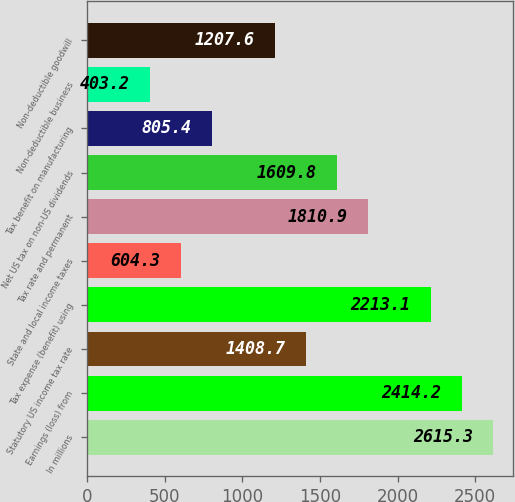<chart> <loc_0><loc_0><loc_500><loc_500><bar_chart><fcel>In millions<fcel>Earnings (loss) from<fcel>Statutory US income tax rate<fcel>Tax expense (benefit) using<fcel>State and local income taxes<fcel>Tax rate and permanent<fcel>Net US tax on non-US dividends<fcel>Tax benefit on manufacturing<fcel>Non-deductible business<fcel>Non-deductible goodwill<nl><fcel>2615.3<fcel>2414.2<fcel>1408.7<fcel>2213.1<fcel>604.3<fcel>1810.9<fcel>1609.8<fcel>805.4<fcel>403.2<fcel>1207.6<nl></chart> 